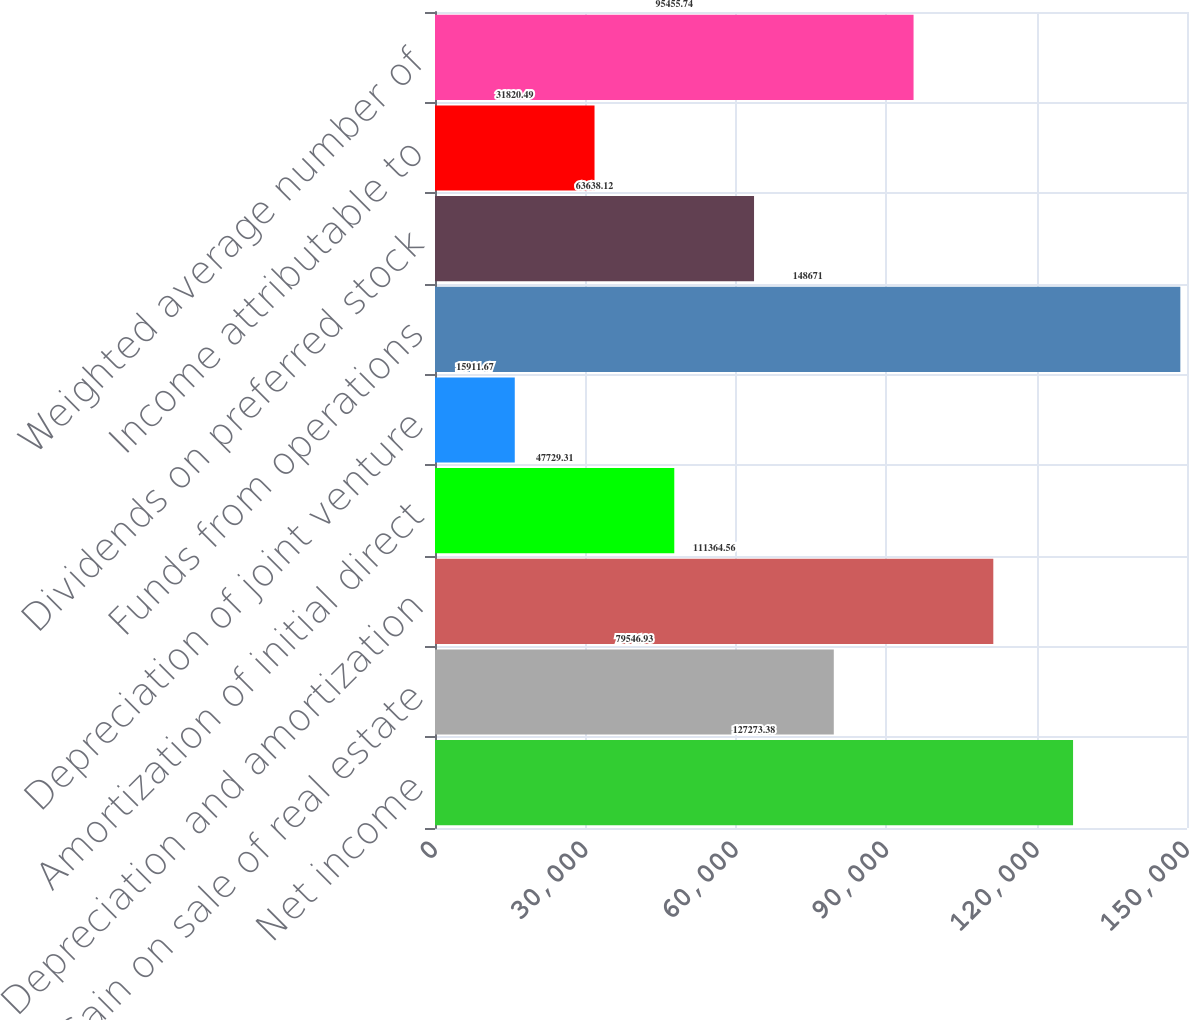Convert chart to OTSL. <chart><loc_0><loc_0><loc_500><loc_500><bar_chart><fcel>Net income<fcel>Gain on sale of real estate<fcel>Depreciation and amortization<fcel>Amortization of initial direct<fcel>Depreciation of joint venture<fcel>Funds from operations<fcel>Dividends on preferred stock<fcel>Income attributable to<fcel>Weighted average number of<nl><fcel>127273<fcel>79546.9<fcel>111365<fcel>47729.3<fcel>15911.7<fcel>148671<fcel>63638.1<fcel>31820.5<fcel>95455.7<nl></chart> 